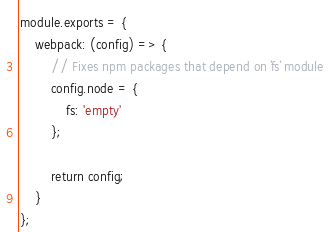Convert code to text. <code><loc_0><loc_0><loc_500><loc_500><_JavaScript_>module.exports = {
    webpack: (config) => {
        // Fixes npm packages that depend on `fs` module
        config.node = {
            fs: 'empty'
        };

        return config;
    }
};
</code> 